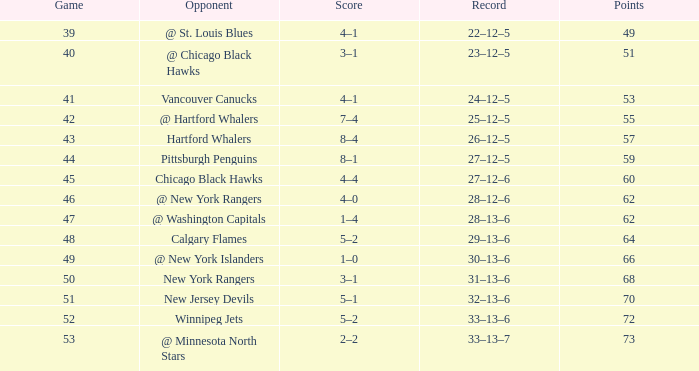Which Points is the lowest one that has a Score of 1–4, and a January smaller than 18? None. 